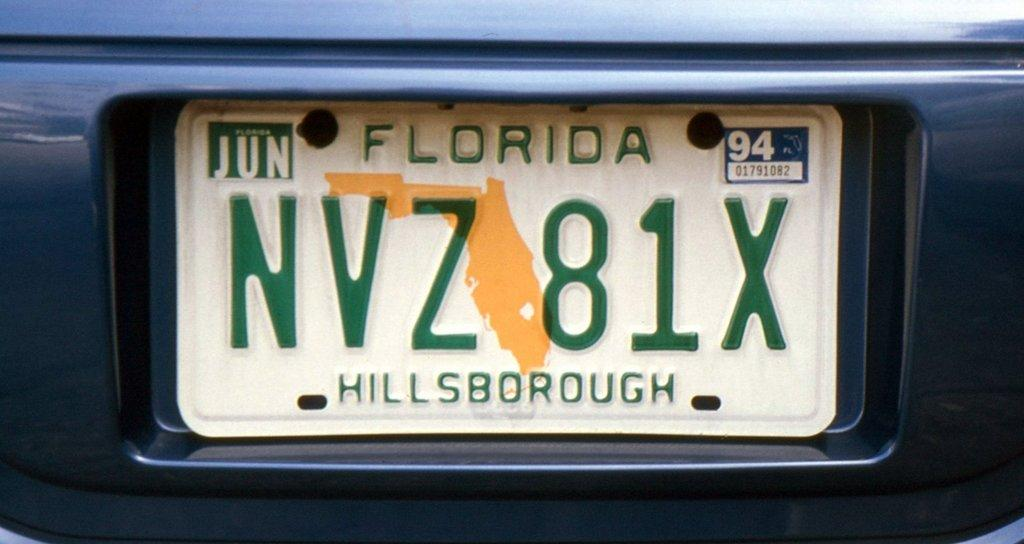<image>
Relay a brief, clear account of the picture shown. A Florida license plate with the number NVZ81X 